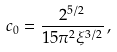<formula> <loc_0><loc_0><loc_500><loc_500>c _ { 0 } = \frac { 2 ^ { 5 / 2 } } { 1 5 \pi ^ { 2 } \xi ^ { 3 / 2 } } \, ,</formula> 